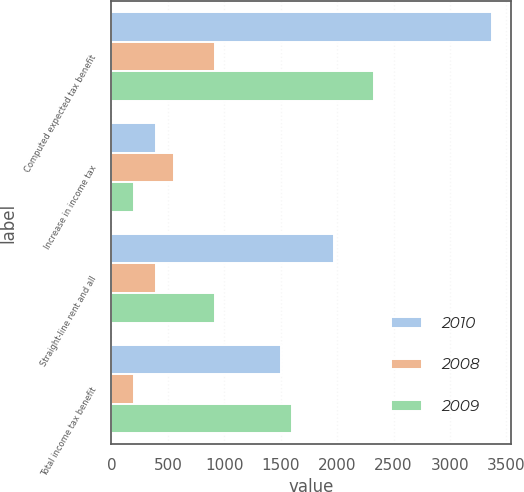<chart> <loc_0><loc_0><loc_500><loc_500><stacked_bar_chart><ecel><fcel>Computed expected tax benefit<fcel>Increase in income tax<fcel>Straight-line rent and all<fcel>Total income tax benefit<nl><fcel>2010<fcel>3368<fcel>392<fcel>1975<fcel>1499<nl><fcel>2008<fcel>921<fcel>558<fcel>392<fcel>202<nl><fcel>2009<fcel>2324<fcel>197<fcel>921<fcel>1600<nl></chart> 